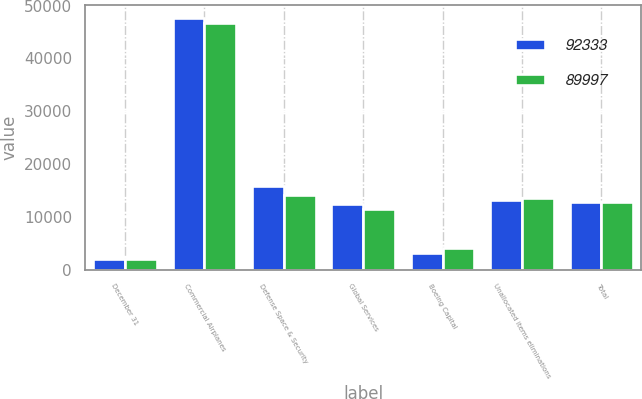Convert chart. <chart><loc_0><loc_0><loc_500><loc_500><stacked_bar_chart><ecel><fcel>December 31<fcel>Commercial Airplanes<fcel>Defense Space & Security<fcel>Global Services<fcel>Boeing Capital<fcel>Unallocated items eliminations<fcel>Total<nl><fcel>92333<fcel>2017<fcel>47737<fcel>15865<fcel>12353<fcel>3156<fcel>13222<fcel>12787.5<nl><fcel>89997<fcel>2016<fcel>46745<fcel>14123<fcel>11490<fcel>4139<fcel>13500<fcel>12787.5<nl></chart> 